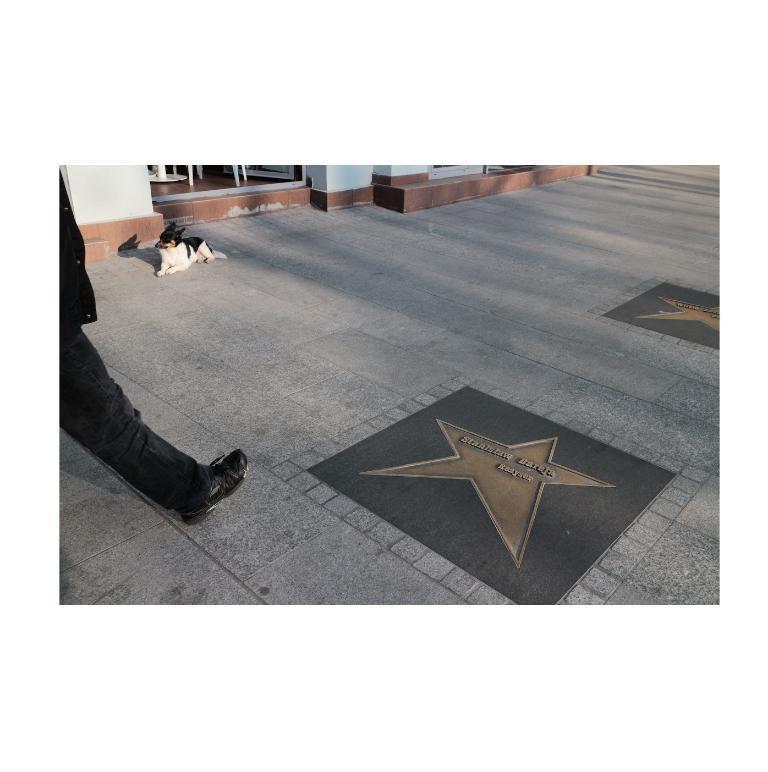In one or two sentences, can you explain what this image depicts? In this image we can see a leg of a person. We can see a dog lying on a floor. On the floor we can see a design and text. At the top we can see few objects and a wall of a building. 